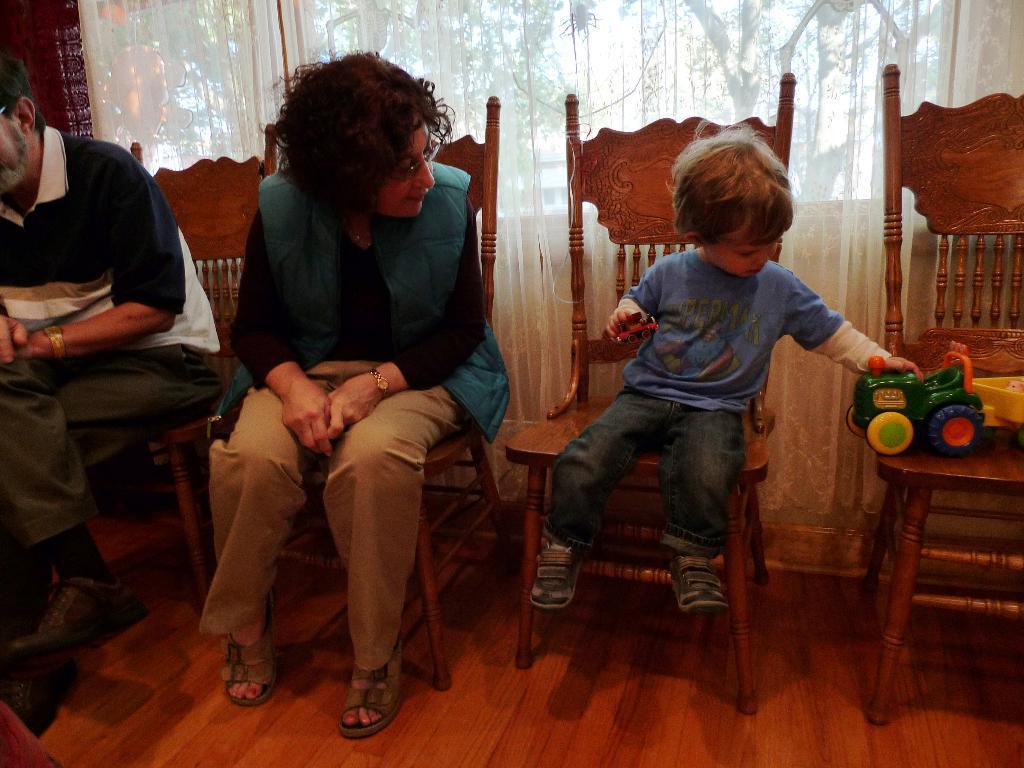Can you describe this image briefly? In the image there are four chairs and on the chairs there is a man, a woman, a kid are sitting and beside the kid on the other chair there is a toy. In the background there is a curtain. 